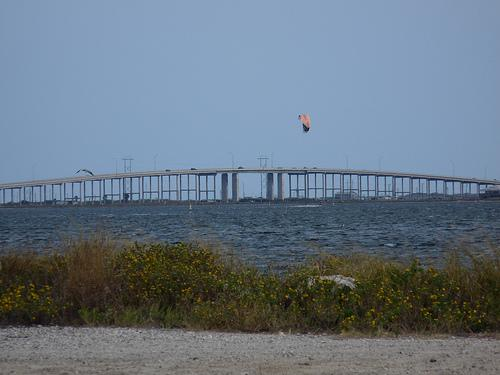Question: where is this photo taken?
Choices:
A. The beach.
B. By a lake.
C. At home.
D. A park.
Answer with the letter. Answer: B Question: who is on the bridge?
Choices:
A. Jumpers.
B. Little kids.
C. Boys.
D. Drivers.
Answer with the letter. Answer: D Question: what kind of road is this?
Choices:
A. Dirt.
B. Cement.
C. Gravel.
D. Stone.
Answer with the letter. Answer: C Question: what color are the flowers in the grass?
Choices:
A. Teal.
B. Yellow.
C. Purple.
D. Neon.
Answer with the letter. Answer: B 